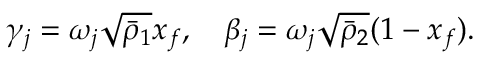<formula> <loc_0><loc_0><loc_500><loc_500>\gamma _ { j } = \omega _ { j } \sqrt { \bar { \rho } _ { 1 } } x _ { f } , \quad \beta _ { j } = \omega _ { j } \sqrt { \bar { \rho } _ { 2 } } ( 1 - x _ { f } ) .</formula> 